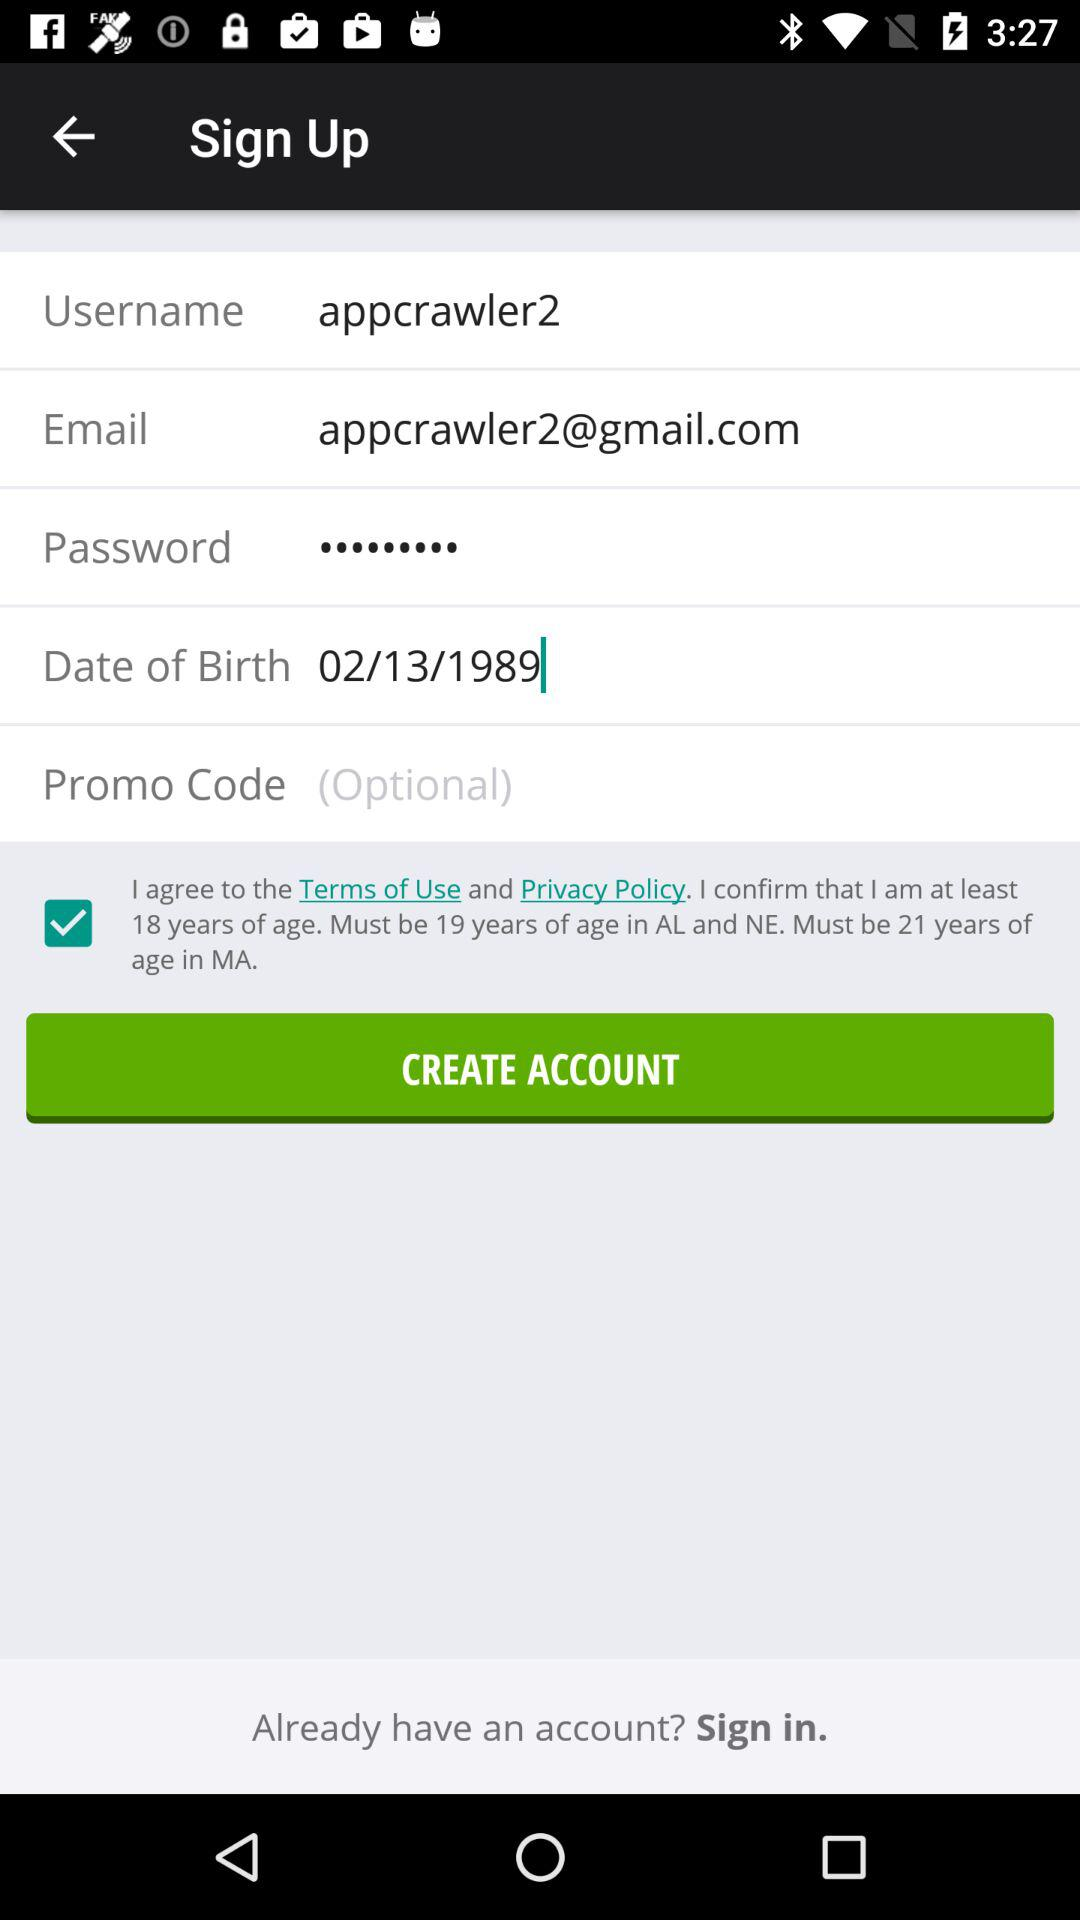What is the status of "Terms of use and privacy policy"? The status is "on". 